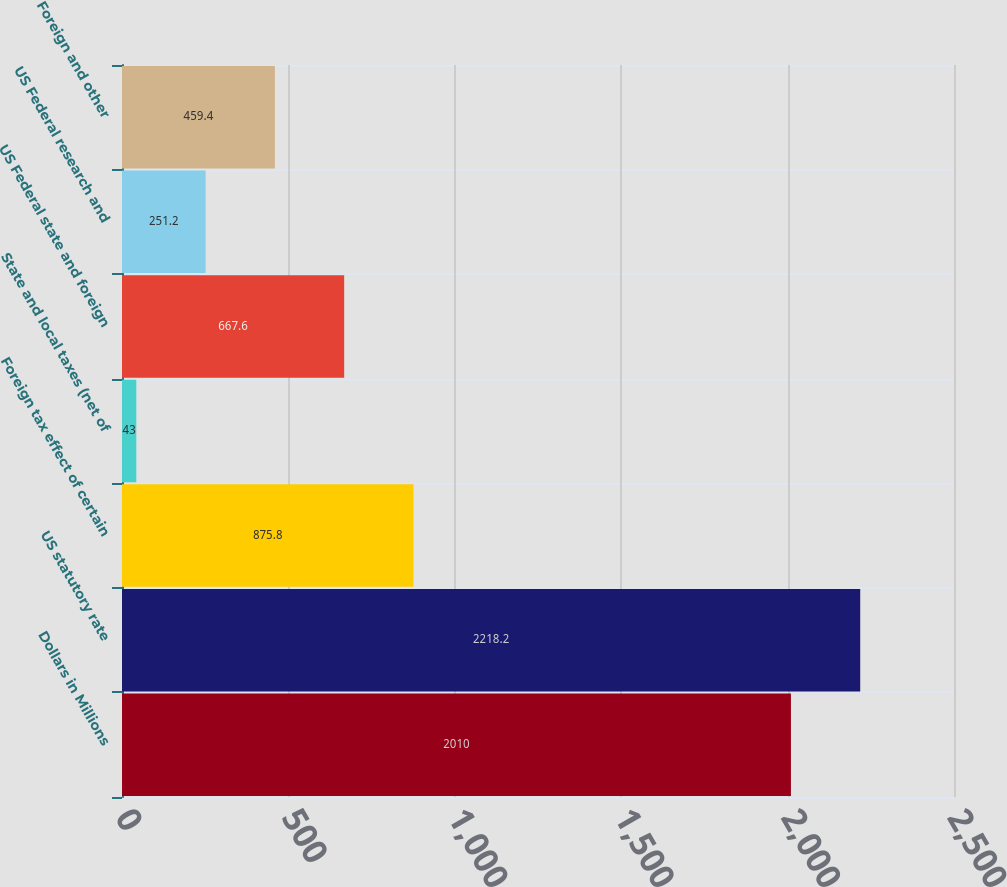Convert chart to OTSL. <chart><loc_0><loc_0><loc_500><loc_500><bar_chart><fcel>Dollars in Millions<fcel>US statutory rate<fcel>Foreign tax effect of certain<fcel>State and local taxes (net of<fcel>US Federal state and foreign<fcel>US Federal research and<fcel>Foreign and other<nl><fcel>2010<fcel>2218.2<fcel>875.8<fcel>43<fcel>667.6<fcel>251.2<fcel>459.4<nl></chart> 